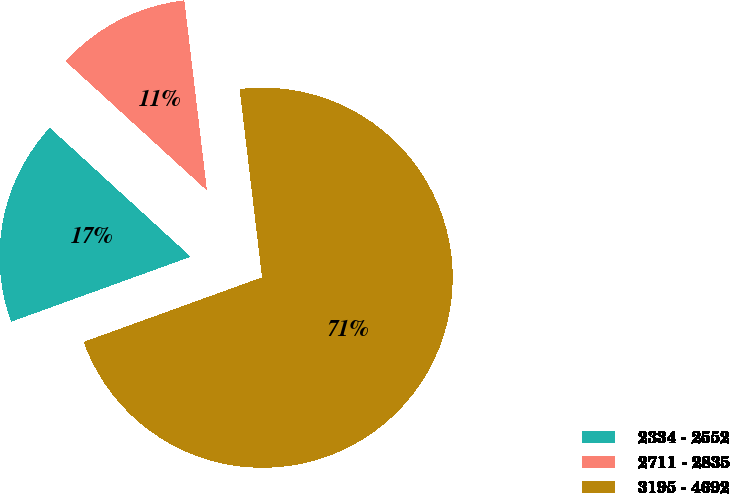Convert chart. <chart><loc_0><loc_0><loc_500><loc_500><pie_chart><fcel>2334 - 2552<fcel>2711 - 2835<fcel>3195 - 4692<nl><fcel>17.32%<fcel>11.32%<fcel>71.36%<nl></chart> 